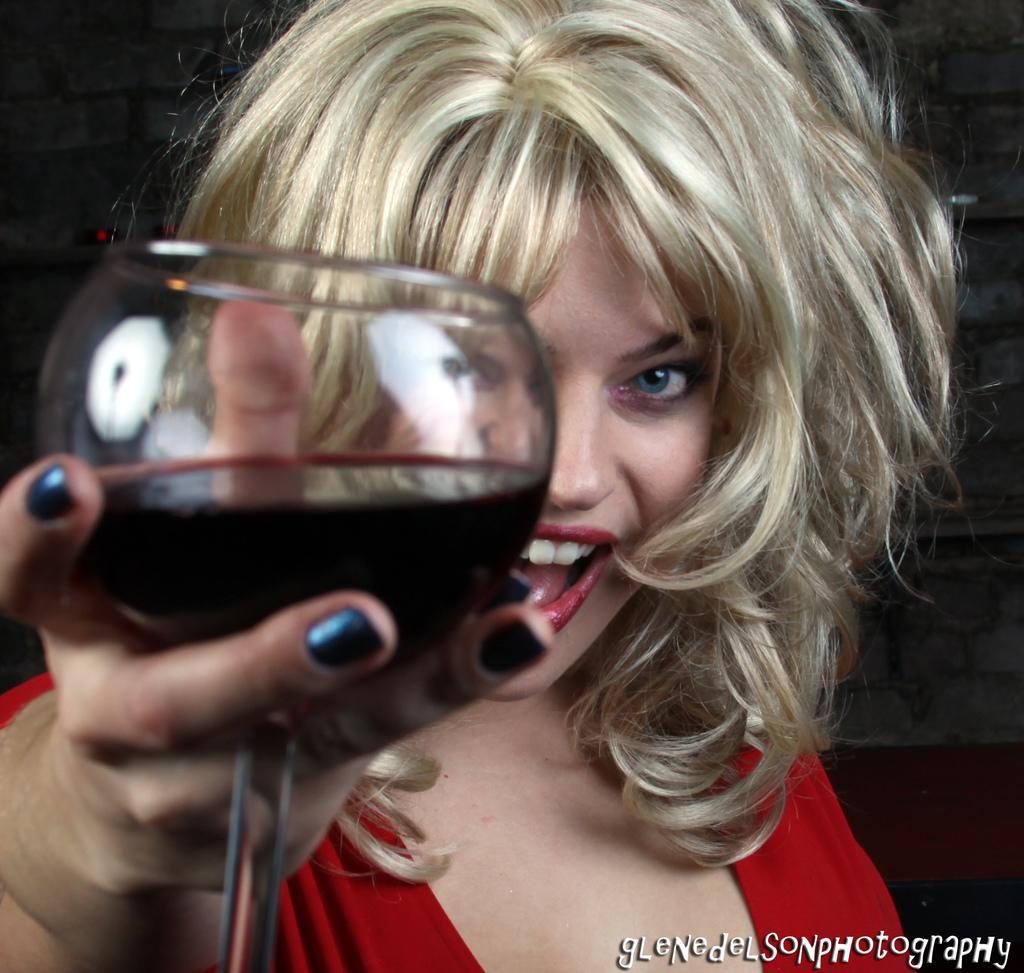Can you describe this image briefly? In this picture there is a girl who is holding a glass , filled with some liquid. 